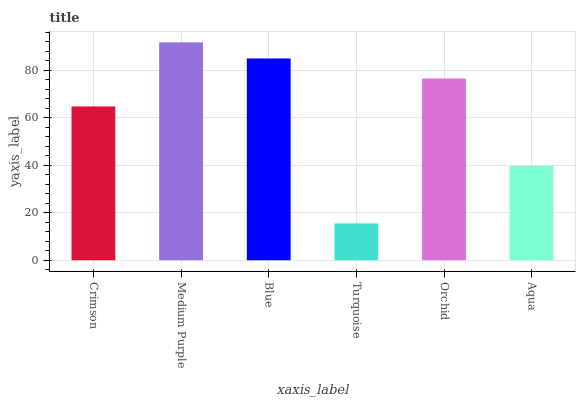Is Turquoise the minimum?
Answer yes or no. Yes. Is Medium Purple the maximum?
Answer yes or no. Yes. Is Blue the minimum?
Answer yes or no. No. Is Blue the maximum?
Answer yes or no. No. Is Medium Purple greater than Blue?
Answer yes or no. Yes. Is Blue less than Medium Purple?
Answer yes or no. Yes. Is Blue greater than Medium Purple?
Answer yes or no. No. Is Medium Purple less than Blue?
Answer yes or no. No. Is Orchid the high median?
Answer yes or no. Yes. Is Crimson the low median?
Answer yes or no. Yes. Is Aqua the high median?
Answer yes or no. No. Is Orchid the low median?
Answer yes or no. No. 